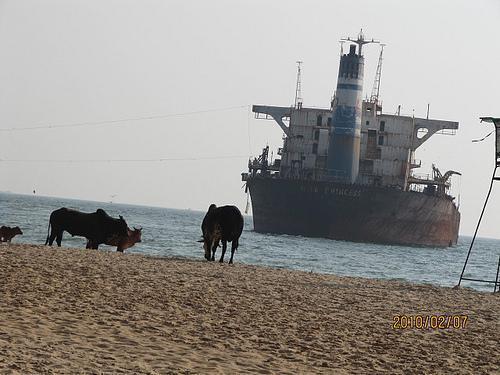How many cows are in the picture?
Give a very brief answer. 4. How many animals are shown?
Give a very brief answer. 4. How many suitcases do you see?
Give a very brief answer. 0. 